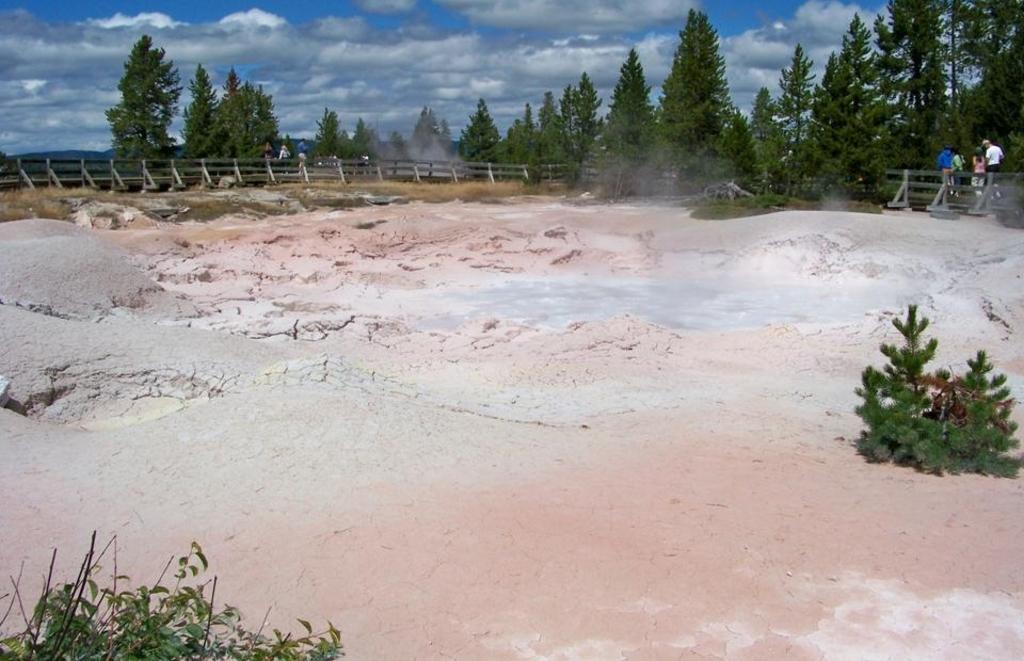Please provide a concise description of this image. In this image we can see trees, here is the fencing, there are the group of people standing on the ground, here are small plants, at above the sky is cloudy. 